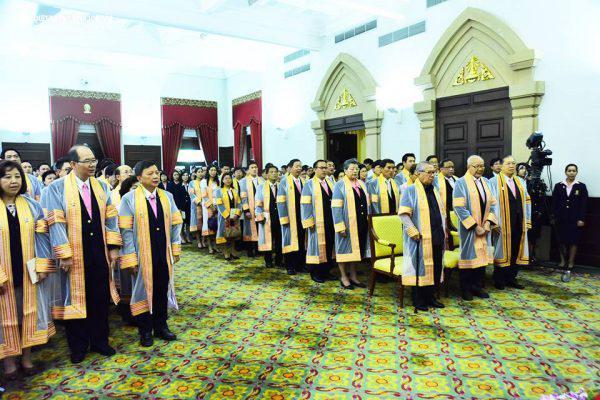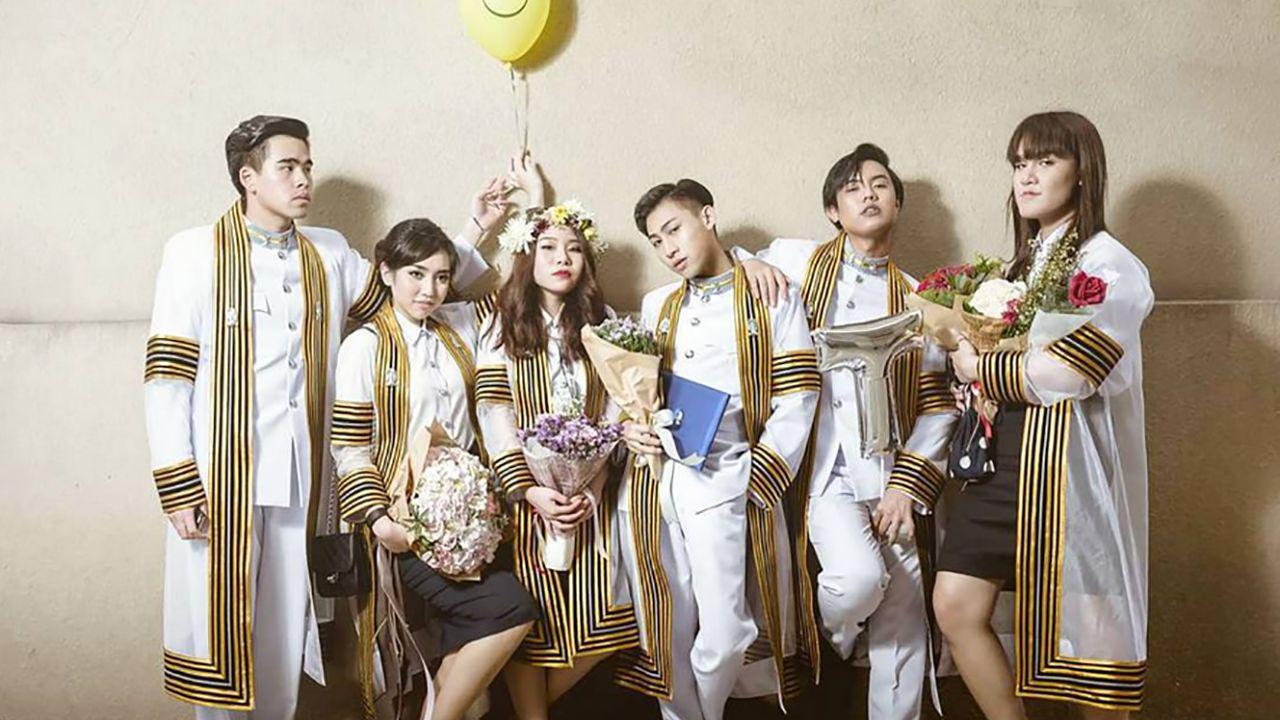The first image is the image on the left, the second image is the image on the right. For the images shown, is this caption "A large congregation of people are lined up in rows outside in at least one picture." true? Answer yes or no. No. The first image is the image on the left, the second image is the image on the right. Evaluate the accuracy of this statement regarding the images: "One of the images features a young man standing in front of a building.". Is it true? Answer yes or no. No. 